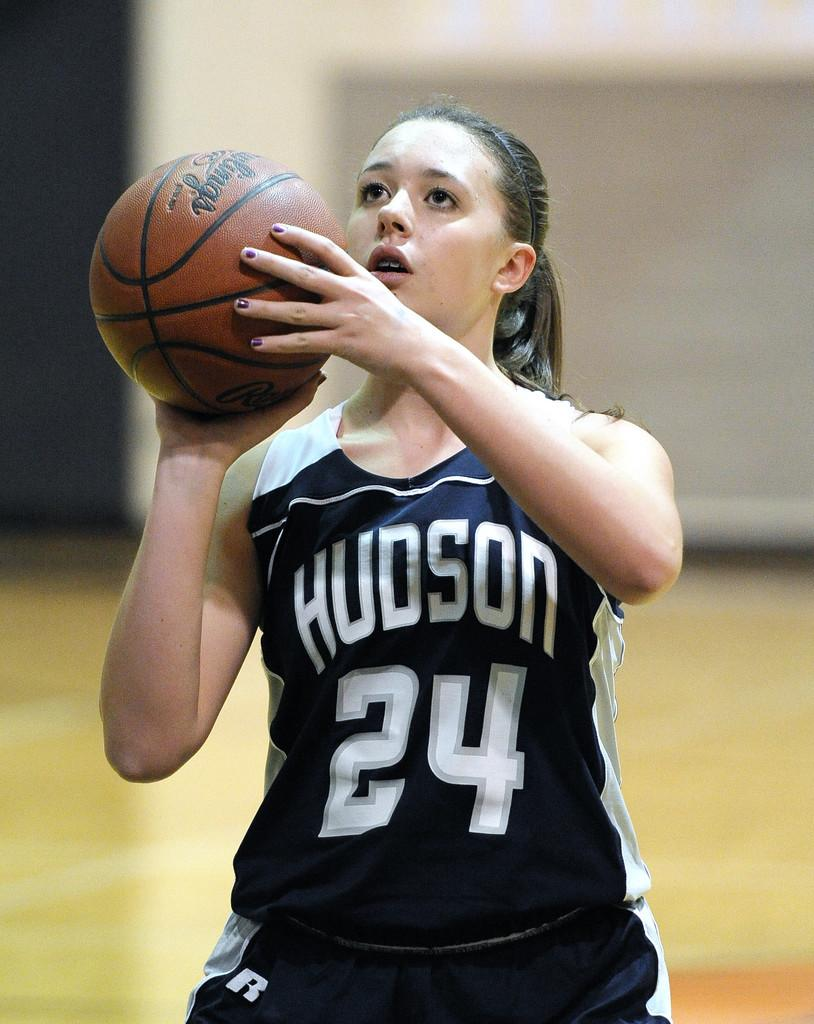<image>
Present a compact description of the photo's key features. A young lady wearing a blue top with Hudson and the number 24 on it, prepares to throw the basketball. 